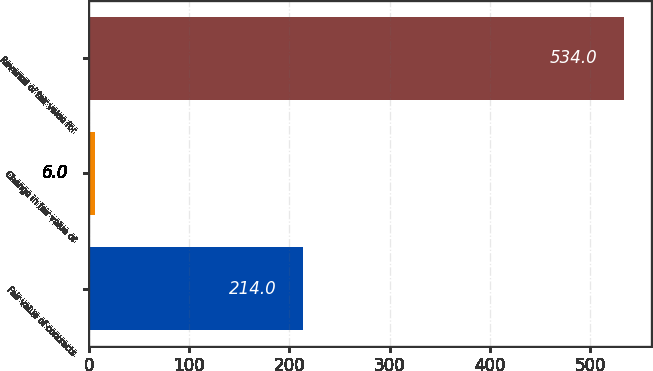Convert chart to OTSL. <chart><loc_0><loc_0><loc_500><loc_500><bar_chart><fcel>Fair value of contracts<fcel>Change in fair value of<fcel>Reversal of fair value for<nl><fcel>214<fcel>6<fcel>534<nl></chart> 